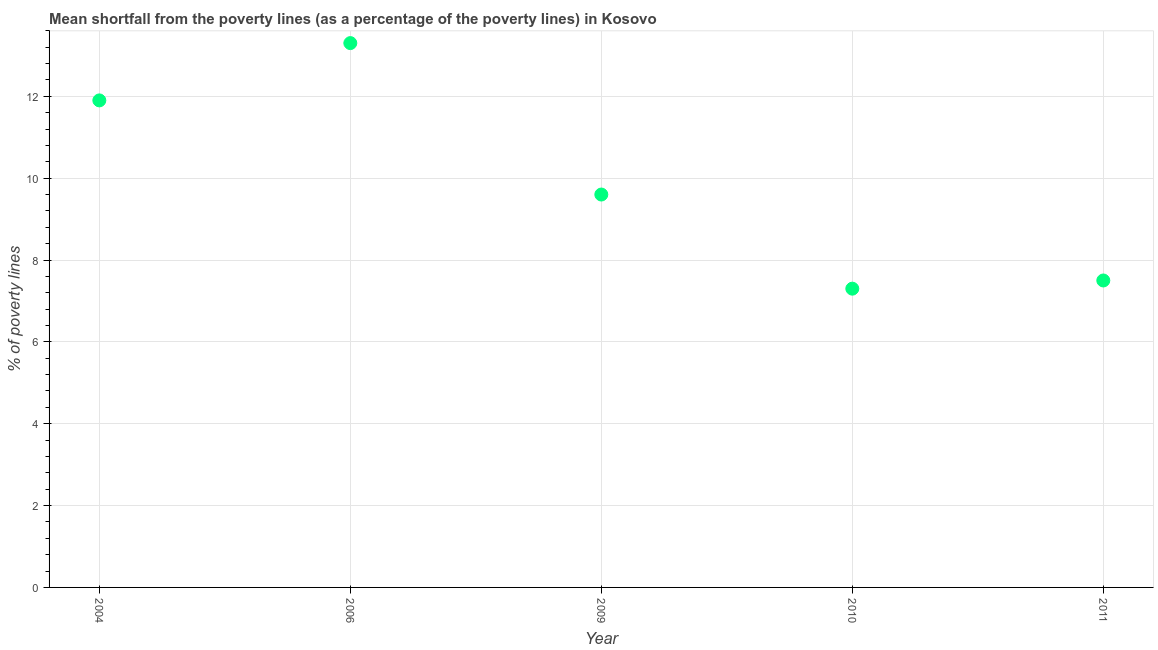Across all years, what is the maximum poverty gap at national poverty lines?
Provide a short and direct response. 13.3. Across all years, what is the minimum poverty gap at national poverty lines?
Keep it short and to the point. 7.3. In which year was the poverty gap at national poverty lines maximum?
Provide a short and direct response. 2006. In which year was the poverty gap at national poverty lines minimum?
Ensure brevity in your answer.  2010. What is the sum of the poverty gap at national poverty lines?
Ensure brevity in your answer.  49.6. What is the difference between the poverty gap at national poverty lines in 2006 and 2010?
Provide a succinct answer. 6. What is the average poverty gap at national poverty lines per year?
Your response must be concise. 9.92. In how many years, is the poverty gap at national poverty lines greater than 2.4 %?
Make the answer very short. 5. What is the ratio of the poverty gap at national poverty lines in 2006 to that in 2010?
Offer a terse response. 1.82. Is the poverty gap at national poverty lines in 2010 less than that in 2011?
Give a very brief answer. Yes. Is the difference between the poverty gap at national poverty lines in 2004 and 2011 greater than the difference between any two years?
Ensure brevity in your answer.  No. What is the difference between the highest and the second highest poverty gap at national poverty lines?
Offer a very short reply. 1.4. Is the sum of the poverty gap at national poverty lines in 2010 and 2011 greater than the maximum poverty gap at national poverty lines across all years?
Keep it short and to the point. Yes. What is the difference between the highest and the lowest poverty gap at national poverty lines?
Your answer should be very brief. 6. How many years are there in the graph?
Give a very brief answer. 5. Does the graph contain any zero values?
Ensure brevity in your answer.  No. What is the title of the graph?
Provide a succinct answer. Mean shortfall from the poverty lines (as a percentage of the poverty lines) in Kosovo. What is the label or title of the Y-axis?
Ensure brevity in your answer.  % of poverty lines. What is the % of poverty lines in 2004?
Ensure brevity in your answer.  11.9. What is the % of poverty lines in 2006?
Provide a succinct answer. 13.3. What is the % of poverty lines in 2010?
Give a very brief answer. 7.3. What is the difference between the % of poverty lines in 2004 and 2009?
Your answer should be compact. 2.3. What is the difference between the % of poverty lines in 2004 and 2010?
Your response must be concise. 4.6. What is the difference between the % of poverty lines in 2006 and 2009?
Offer a very short reply. 3.7. What is the difference between the % of poverty lines in 2006 and 2011?
Keep it short and to the point. 5.8. What is the difference between the % of poverty lines in 2009 and 2010?
Your response must be concise. 2.3. What is the difference between the % of poverty lines in 2010 and 2011?
Give a very brief answer. -0.2. What is the ratio of the % of poverty lines in 2004 to that in 2006?
Offer a very short reply. 0.9. What is the ratio of the % of poverty lines in 2004 to that in 2009?
Provide a succinct answer. 1.24. What is the ratio of the % of poverty lines in 2004 to that in 2010?
Make the answer very short. 1.63. What is the ratio of the % of poverty lines in 2004 to that in 2011?
Make the answer very short. 1.59. What is the ratio of the % of poverty lines in 2006 to that in 2009?
Ensure brevity in your answer.  1.39. What is the ratio of the % of poverty lines in 2006 to that in 2010?
Offer a very short reply. 1.82. What is the ratio of the % of poverty lines in 2006 to that in 2011?
Your answer should be very brief. 1.77. What is the ratio of the % of poverty lines in 2009 to that in 2010?
Your answer should be compact. 1.31. What is the ratio of the % of poverty lines in 2009 to that in 2011?
Give a very brief answer. 1.28. 